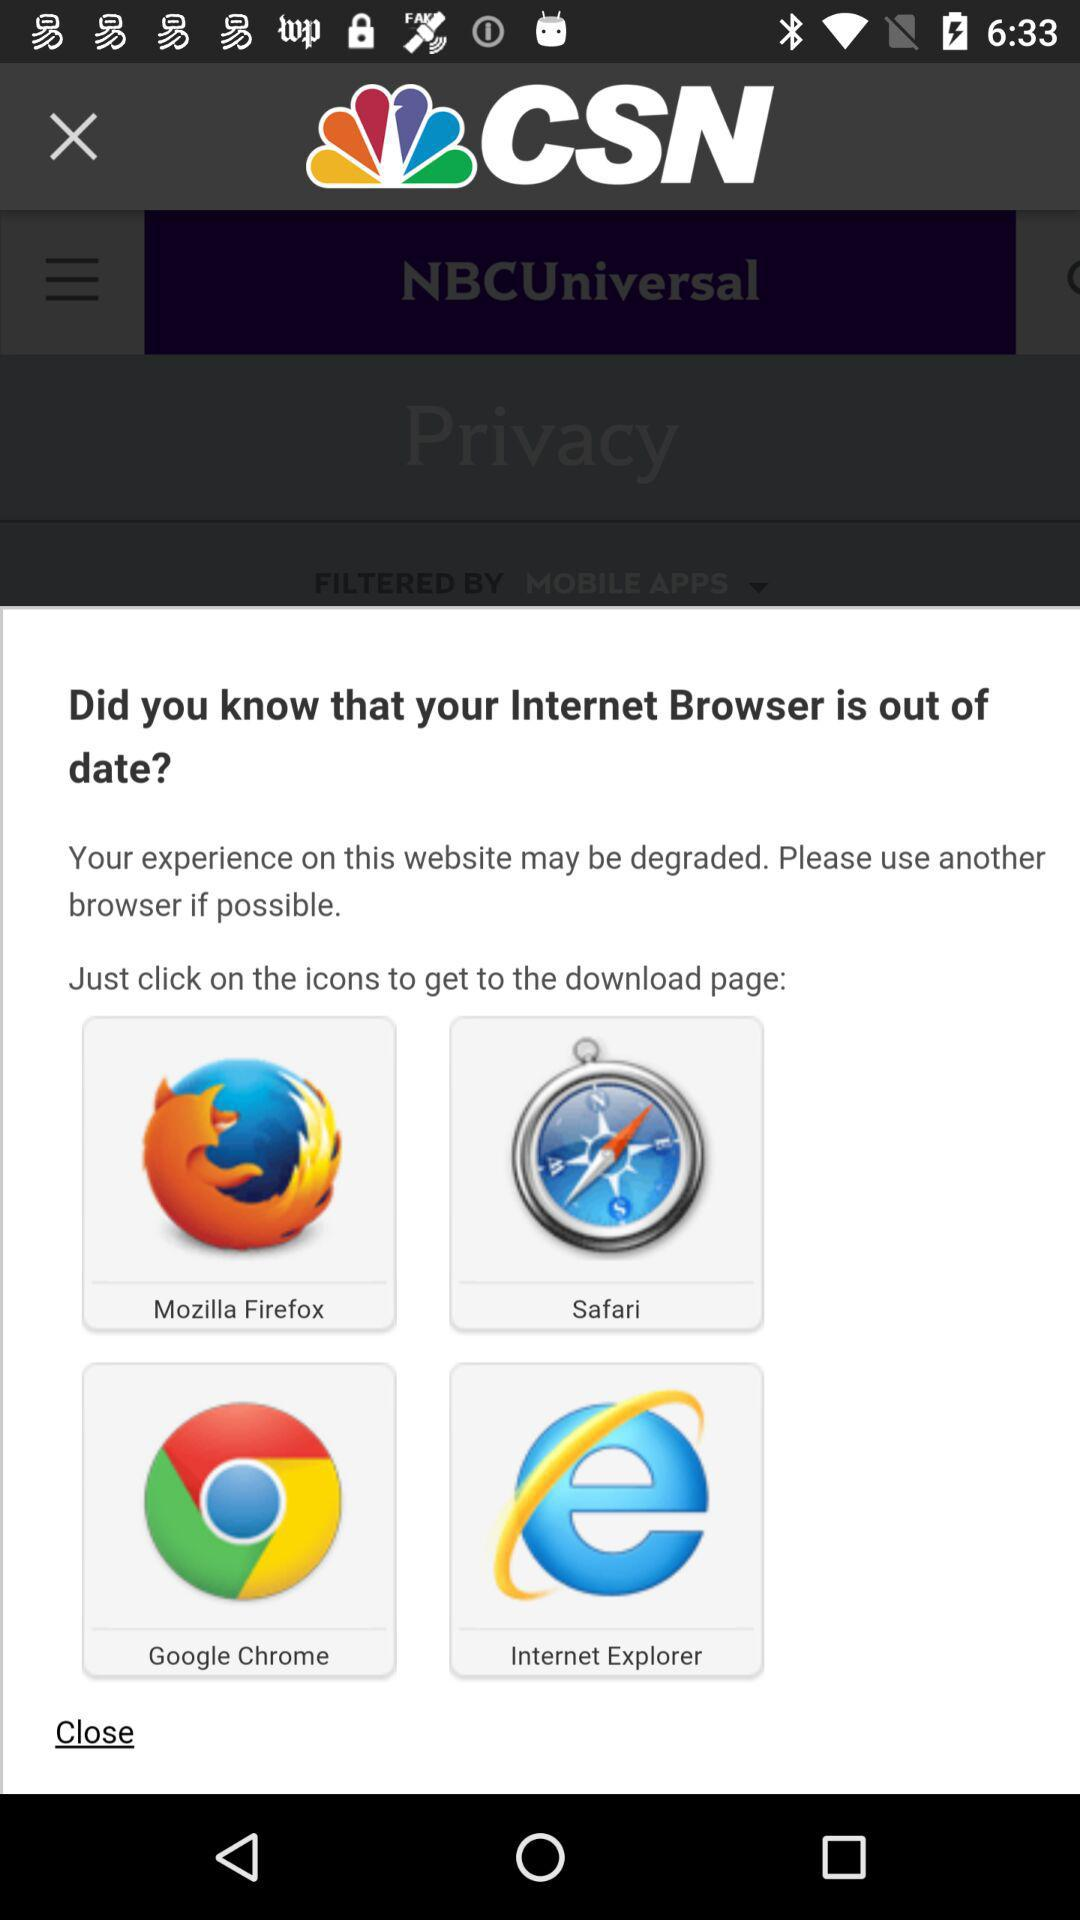What are the browser options to get to the download page? The browser options to get to the download page are "Mozilla Firefox", "Safari", "Google Chrome" and "Internet Explorer". 